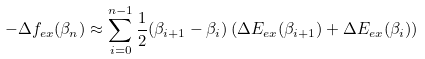<formula> <loc_0><loc_0><loc_500><loc_500>- \Delta f _ { e x } ( \beta _ { n } ) \approx \sum _ { i = 0 } ^ { n - 1 } \frac { 1 } { 2 } ( \beta _ { i + 1 } - \beta _ { i } ) \left ( \Delta E _ { e x } ( \beta _ { i + 1 } ) + \Delta E _ { e x } ( \beta _ { i } ) \right )</formula> 